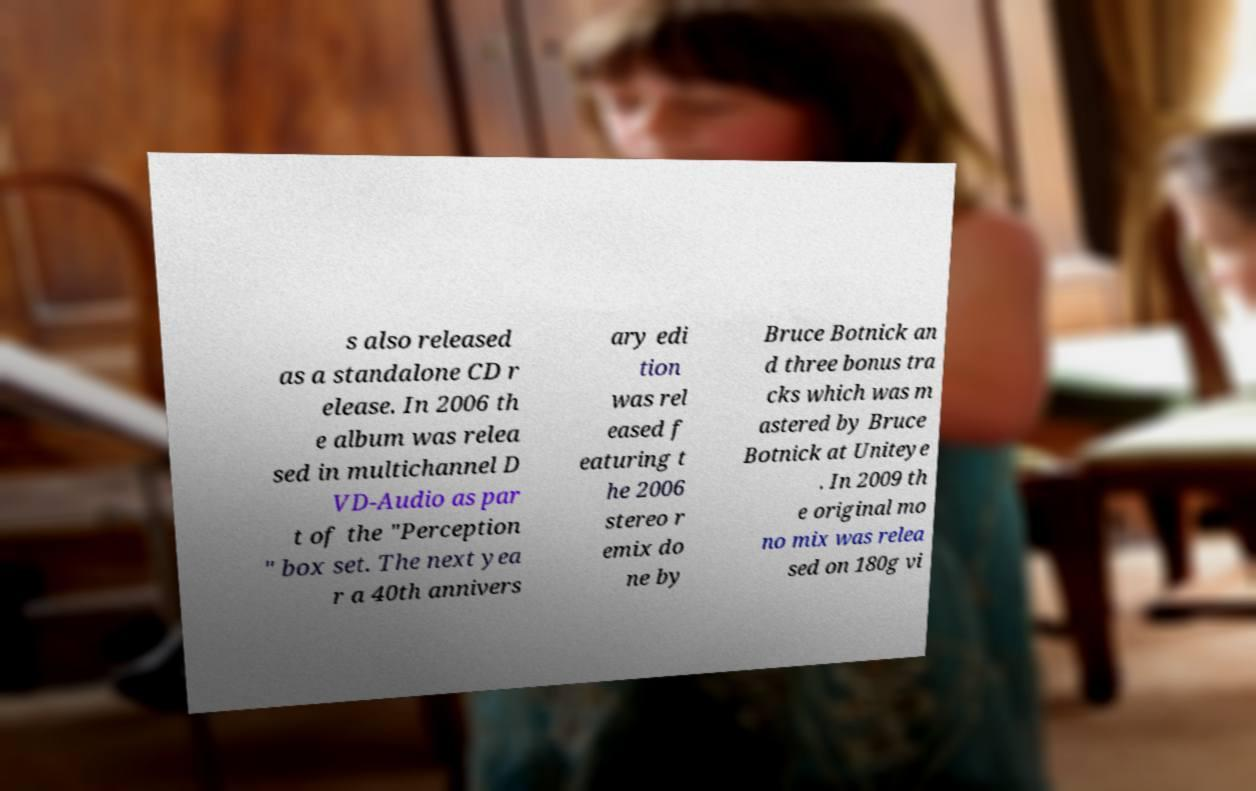Could you assist in decoding the text presented in this image and type it out clearly? s also released as a standalone CD r elease. In 2006 th e album was relea sed in multichannel D VD-Audio as par t of the "Perception " box set. The next yea r a 40th annivers ary edi tion was rel eased f eaturing t he 2006 stereo r emix do ne by Bruce Botnick an d three bonus tra cks which was m astered by Bruce Botnick at Uniteye . In 2009 th e original mo no mix was relea sed on 180g vi 